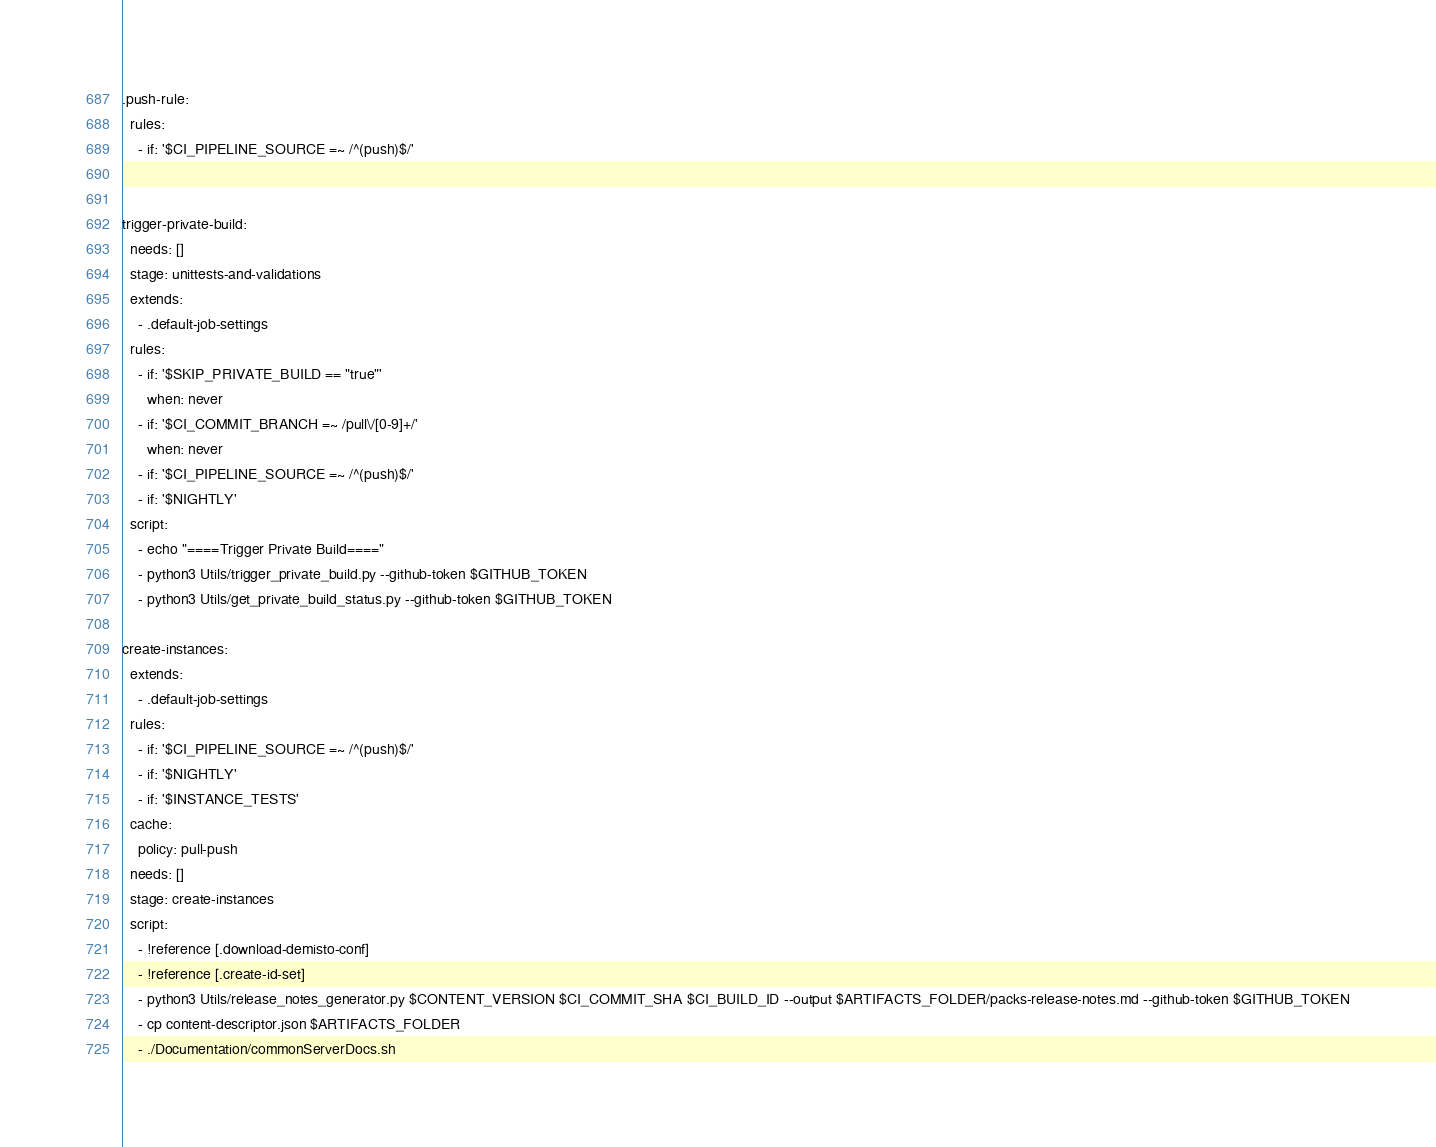Convert code to text. <code><loc_0><loc_0><loc_500><loc_500><_YAML_>.push-rule:
  rules:
    - if: '$CI_PIPELINE_SOURCE =~ /^(push)$/'


trigger-private-build:
  needs: []
  stage: unittests-and-validations
  extends:
    - .default-job-settings
  rules:
    - if: '$SKIP_PRIVATE_BUILD == "true"'
      when: never
    - if: '$CI_COMMIT_BRANCH =~ /pull\/[0-9]+/'
      when: never
    - if: '$CI_PIPELINE_SOURCE =~ /^(push)$/'
    - if: '$NIGHTLY'
  script:
    - echo "====Trigger Private Build===="
    - python3 Utils/trigger_private_build.py --github-token $GITHUB_TOKEN
    - python3 Utils/get_private_build_status.py --github-token $GITHUB_TOKEN

create-instances:
  extends:
    - .default-job-settings
  rules:
    - if: '$CI_PIPELINE_SOURCE =~ /^(push)$/'
    - if: '$NIGHTLY'
    - if: '$INSTANCE_TESTS'
  cache:
    policy: pull-push
  needs: []
  stage: create-instances
  script:
    - !reference [.download-demisto-conf]
    - !reference [.create-id-set]
    - python3 Utils/release_notes_generator.py $CONTENT_VERSION $CI_COMMIT_SHA $CI_BUILD_ID --output $ARTIFACTS_FOLDER/packs-release-notes.md --github-token $GITHUB_TOKEN
    - cp content-descriptor.json $ARTIFACTS_FOLDER
    - ./Documentation/commonServerDocs.sh</code> 